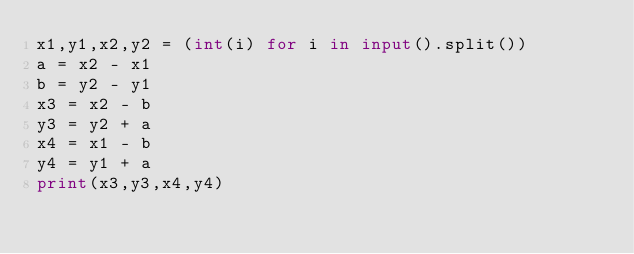<code> <loc_0><loc_0><loc_500><loc_500><_Python_>x1,y1,x2,y2 = (int(i) for i in input().split())
a = x2 - x1
b = y2 - y1
x3 = x2 - b
y3 = y2 + a
x4 = x1 - b
y4 = y1 + a
print(x3,y3,x4,y4)</code> 